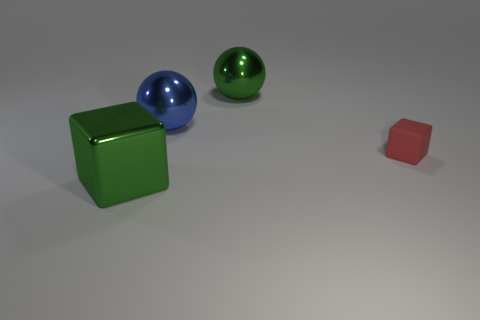This arrangement of objects could tell a story. Could they represent anything symbolically? One could interpret the arrangement as symbolic of numerical progression or hierarchy, with the small red cube representing the number one, and each subsequent object increasing in size and perhaps conceptual complexity. It's also possible to see them as standing in for different elements—earth represented by the cube, and water or air by the spheres due to their fluid characteristics. 